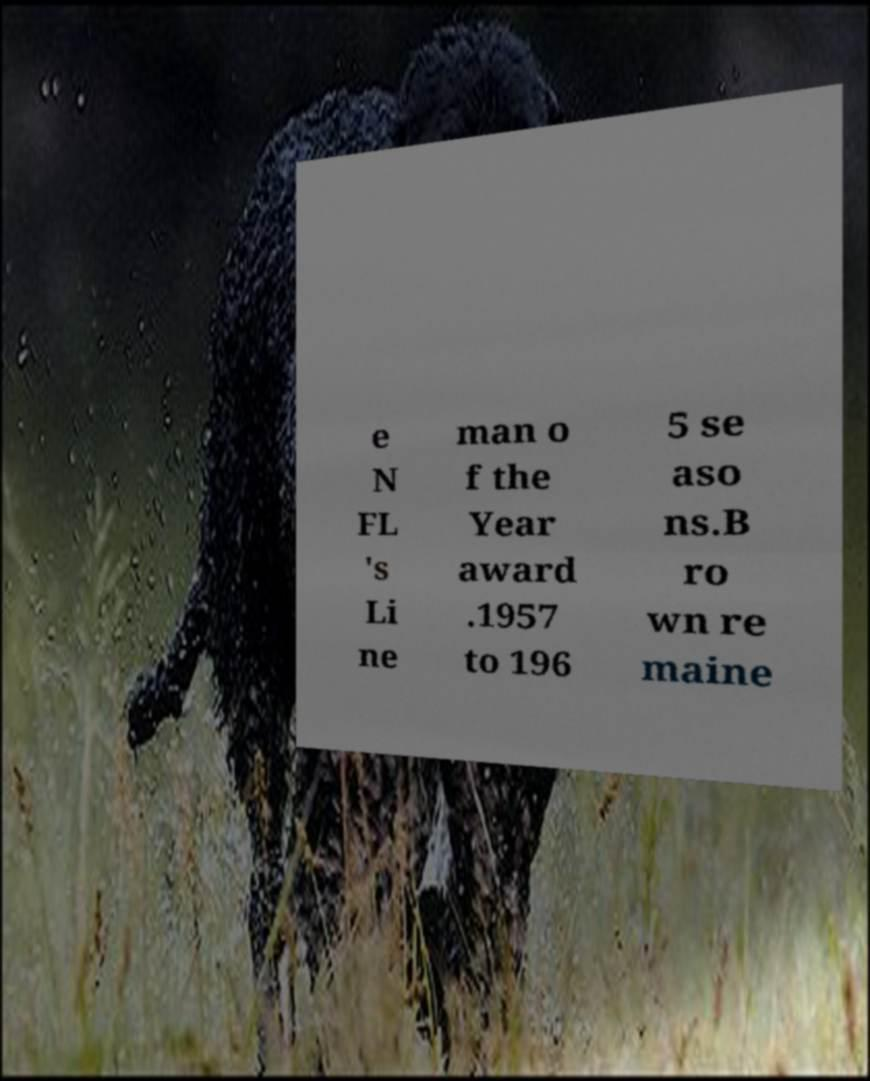Please read and relay the text visible in this image. What does it say? e N FL 's Li ne man o f the Year award .1957 to 196 5 se aso ns.B ro wn re maine 